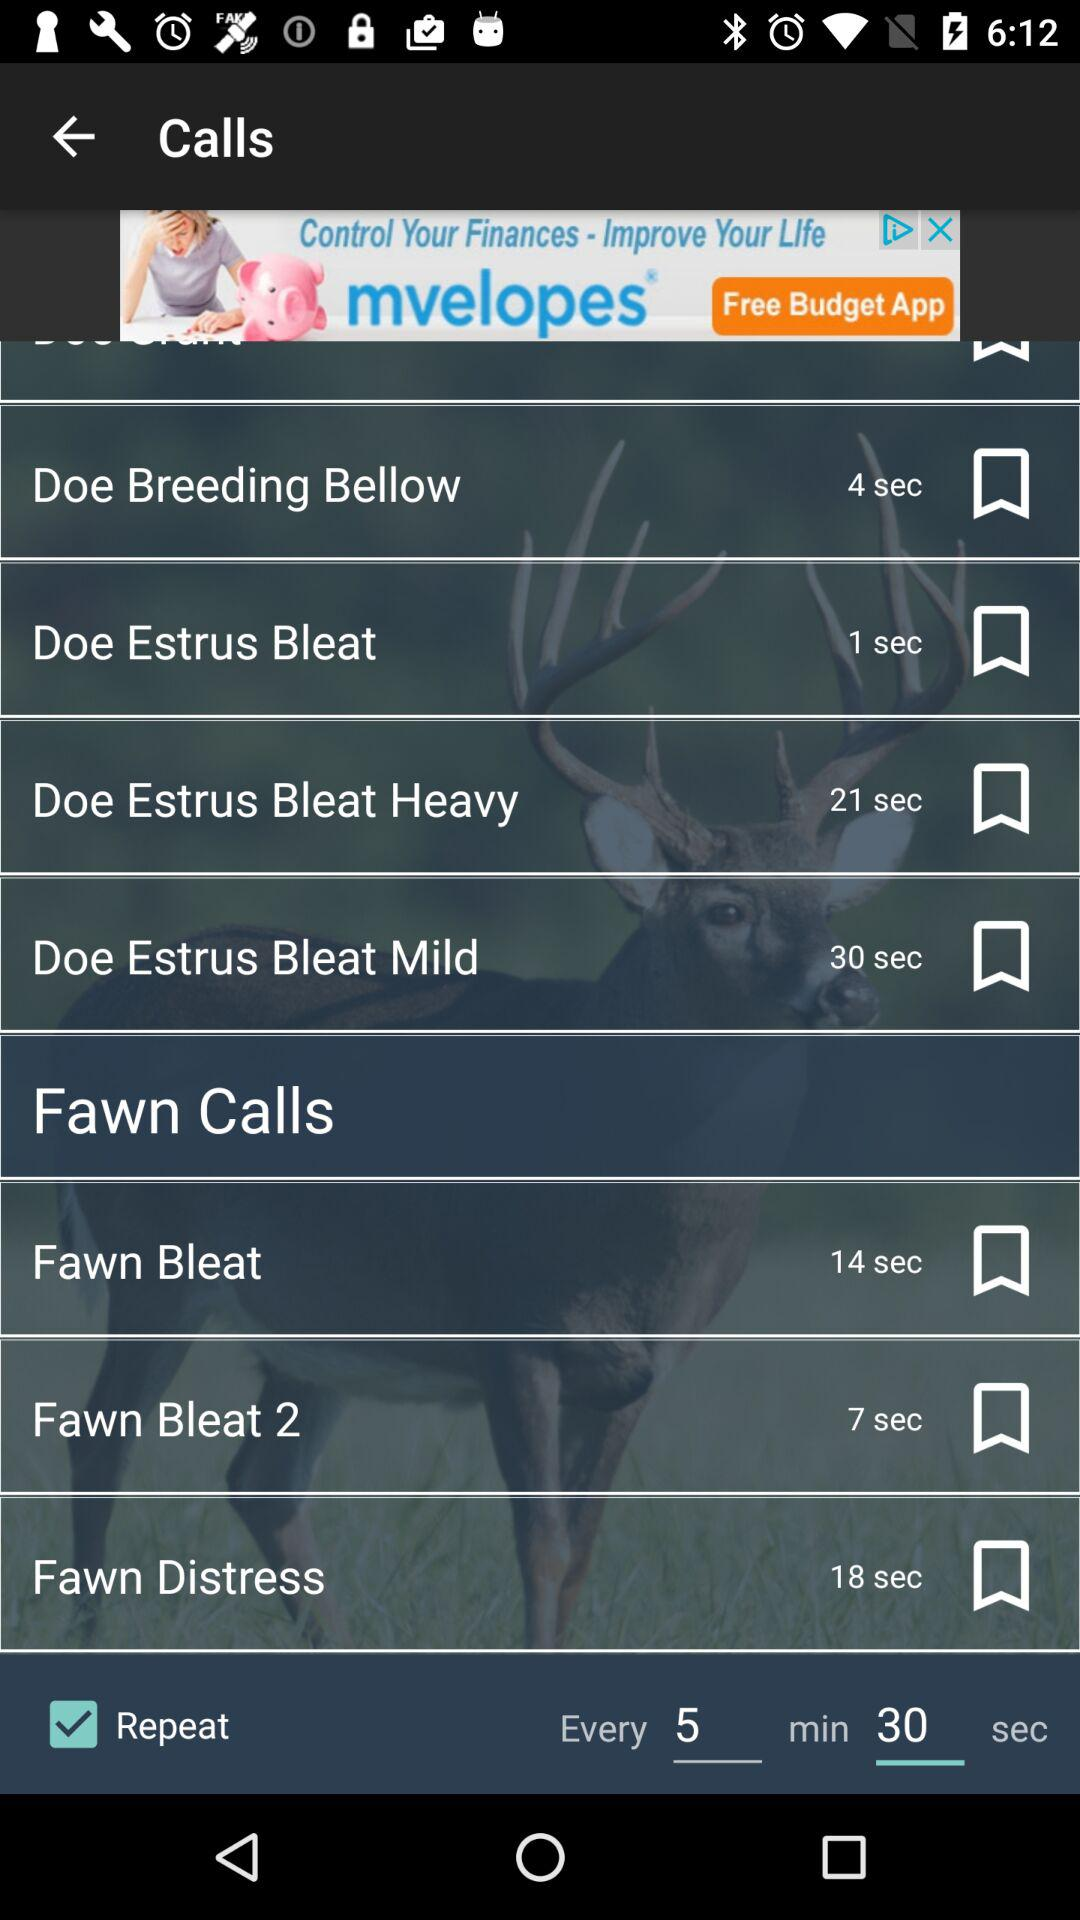What is the duration of the call "Fawn Bleat"? The duration of the call is 14 seconds. 